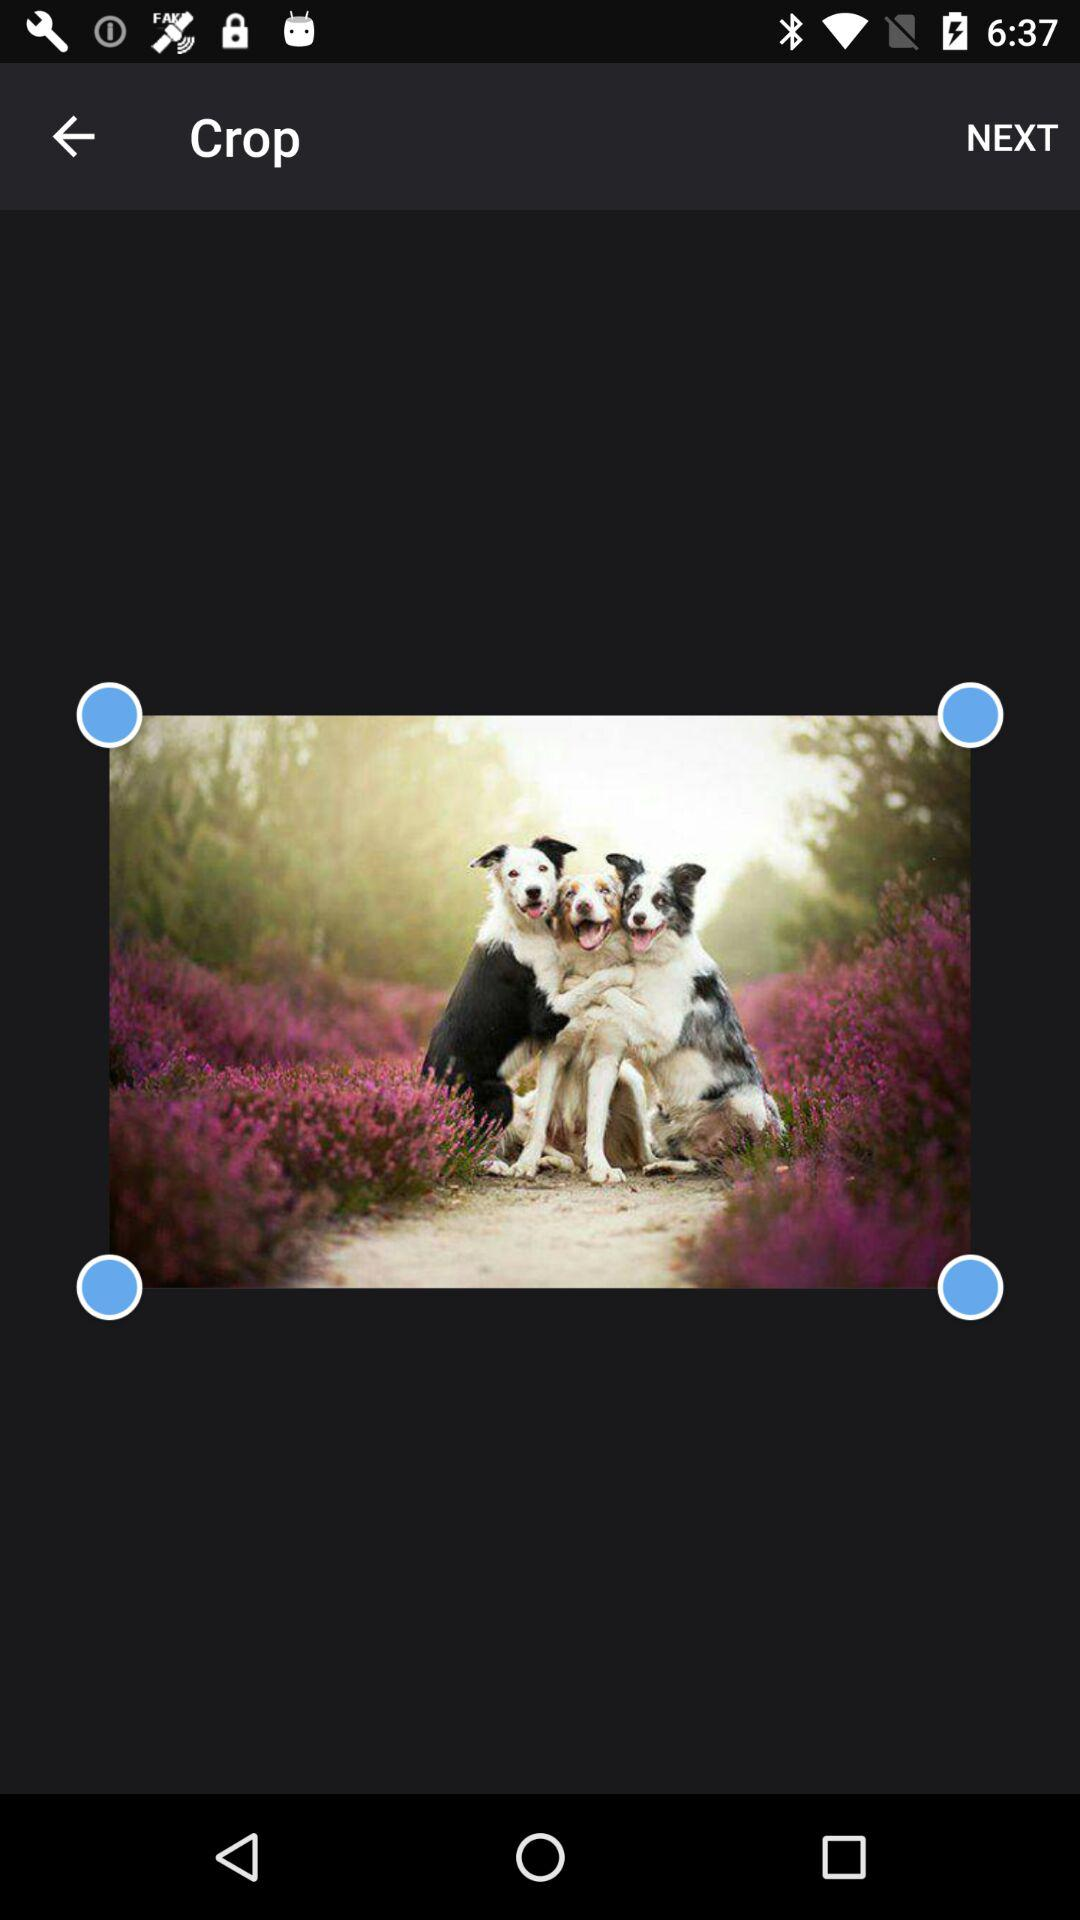How many blue circles with a white border are there?
Answer the question using a single word or phrase. 4 